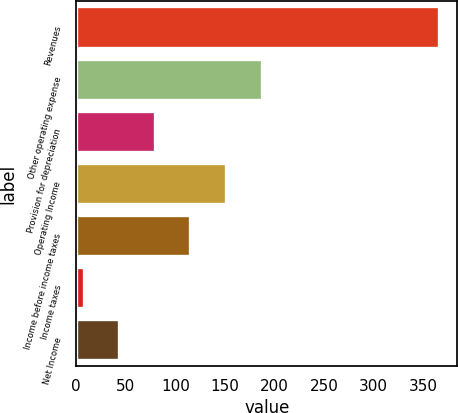Convert chart to OTSL. <chart><loc_0><loc_0><loc_500><loc_500><bar_chart><fcel>Revenues<fcel>Other operating expense<fcel>Provision for depreciation<fcel>Operating Income<fcel>Income before income taxes<fcel>Income taxes<fcel>Net Income<nl><fcel>366.5<fcel>187.05<fcel>79.38<fcel>151.16<fcel>115.27<fcel>7.6<fcel>43.49<nl></chart> 